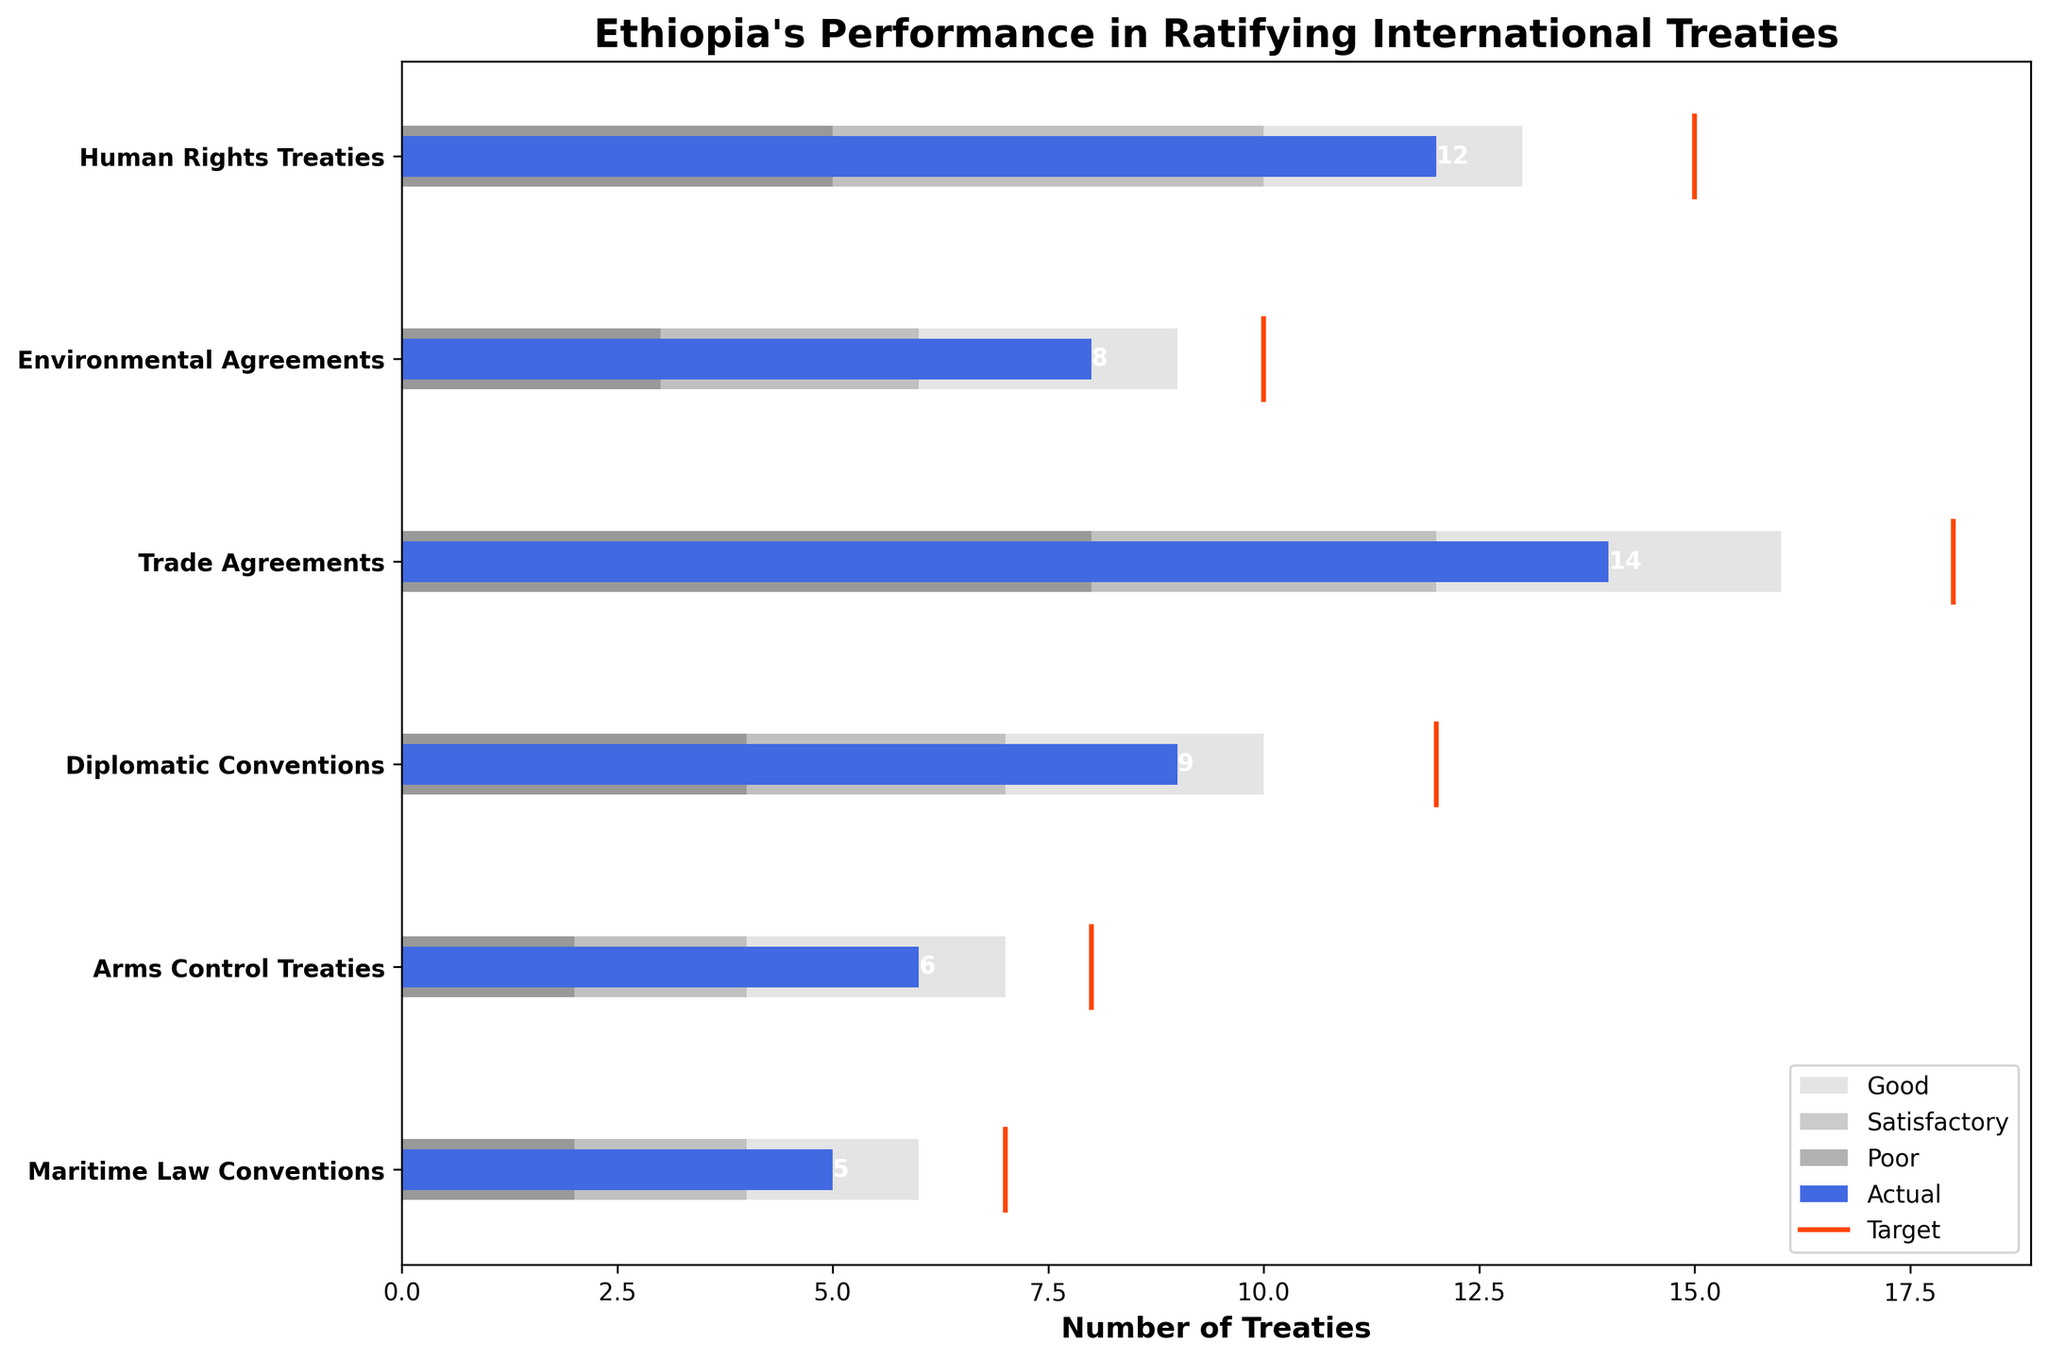what is the title of the plot? The title is the text at the top of the plot. In this plot, it reads "Ethiopia's Performance in Ratifying International Treaties."
Answer: Ethiopia's Performance in Ratifying International Treaties For how many categories did Ethiopia meet or exceed the 'Good' threshold? The 'Good' threshold is represented by the lightest gray bar. If the blue 'Actual' bar reaches or exceeds it, the threshold is met or exceeded. By observing the plot, Ethiopia met or exceeded the 'Good' threshold in two categories: Human Rights Treaties and Trade Agreements.
Answer: 2 Which category has the highest target for ratified treaties? The target values are indicated by red lines for each category. By looking at their positions, Trade Agreements has the highest target at 18 treaties.
Answer: Trade Agreements Is Ethiopia's performance closer to its target in Human Rights Treaties or Environmental Agreements? To assess closeness to the target, compare the difference between the 'Actual' blue bar and the Target red line for both categories. For Human Rights Treaties, the difference is 3 (15-12), and for Environmental Agreements, it's 2 (10-8). Thus, Ethiopia's performance is closer to its target in Environmental Agreements.
Answer: Environmental Agreements How many treaties does Ethiopia need to ratify to move from 'Poor' to 'Satisfactory' in Maritime Law Conventions? The 'Poor' and 'Satisfactory' are indicated by the darkest and mid-gray sections of the bar, respectively. To move from 'Poor' to 'Satisfactory', Ethiopia needs to reach the lower bound of 'Satisfactory', which is 4 treaties, but they have 5 already: No additional treaties are needed.
Answer: 0 Which of the categories meet or exceed their 'Satisfactory' thresholds? The 'Satisfactory' threshold is represented by the mid-gray bar. Any category with a blue 'Actual' bar that reaches or exceeds this belongs here. They are: Human Rights Treaties (12 >= 10), Trade Agreements (14 >= 12), and Diplomatic Conventions (9 >= 7).
Answer: Human Rights Treaties, Trade Agreements, Diplomatic Conventions In which treaty category is Ethiopia's actual value furthest from the target? The distances from the actual values to the targets can be calculated by subtracting the actual number from the target in each category. Human Rights Treaties: 3, Environmental Agreements: 2, Trade Agreements: 4, Diplomatic Conventions: 3, Arms Control Treaties: 2, Maritime Law Conventions: 2. The largest gap of 4 is found in Trade Agreements.
Answer: Trade Agreements What can you infer about Ethiopia's overall performance in ratifying Arms Control Treaties based on the visual data? For Arms Control Treaties, the actual number of treaties is 6, which is within the 'Good' range (below the target of 8 but above 'Poor'). This implies satisfactory advancement but not top performance yet.
Answer: Satisfactory 